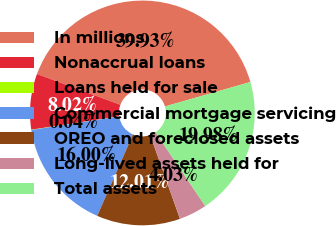Convert chart to OTSL. <chart><loc_0><loc_0><loc_500><loc_500><pie_chart><fcel>In millions<fcel>Nonaccrual loans<fcel>Loans held for sale<fcel>Commercial mortgage servicing<fcel>OREO and foreclosed assets<fcel>Long-lived assets held for<fcel>Total assets<nl><fcel>39.93%<fcel>8.02%<fcel>0.04%<fcel>16.0%<fcel>12.01%<fcel>4.03%<fcel>19.98%<nl></chart> 